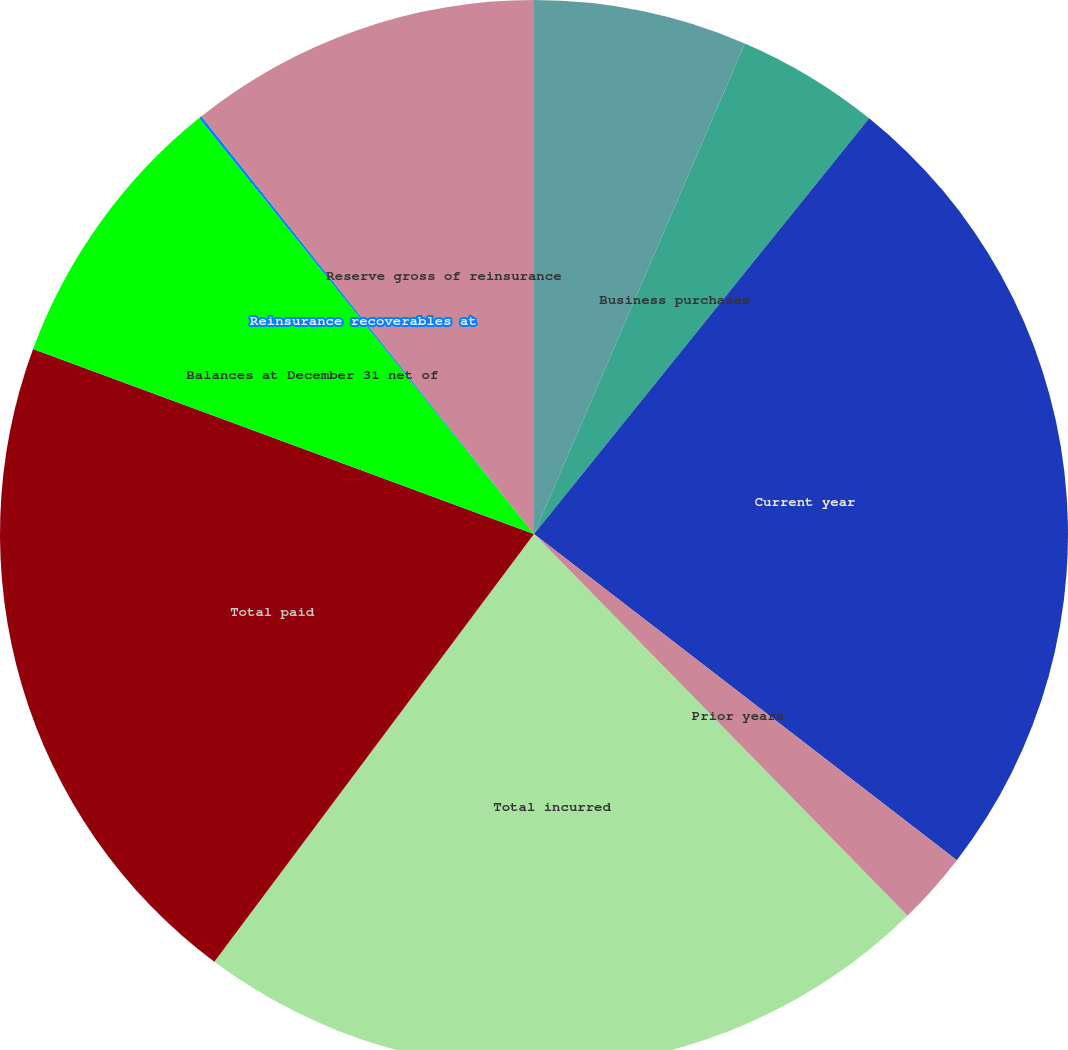<chart> <loc_0><loc_0><loc_500><loc_500><pie_chart><fcel>Balances at January 1 net of<fcel>Business purchases<fcel>Current year<fcel>Prior years<fcel>Total incurred<fcel>Total paid<fcel>Balances at December 31 net of<fcel>Reinsurance recoverables at<fcel>Reserve gross of reinsurance<nl><fcel>6.46%<fcel>4.34%<fcel>24.66%<fcel>2.22%<fcel>22.54%<fcel>20.42%<fcel>8.58%<fcel>0.09%<fcel>10.7%<nl></chart> 